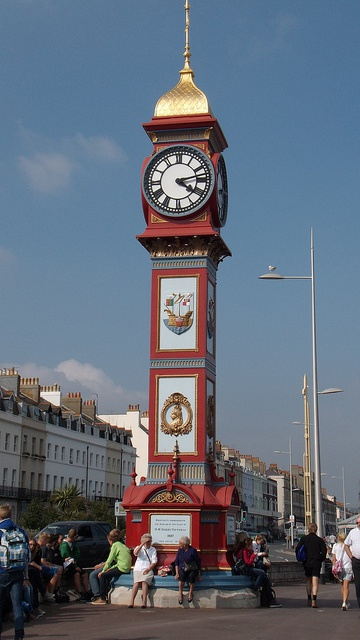Describe the objects in this image and their specific colors. I can see people in gray, black, and maroon tones, clock in gray, lightgray, black, and darkgray tones, people in gray, black, navy, and darkgray tones, car in gray, black, and purple tones, and bench in gray, black, blue, and darkblue tones in this image. 